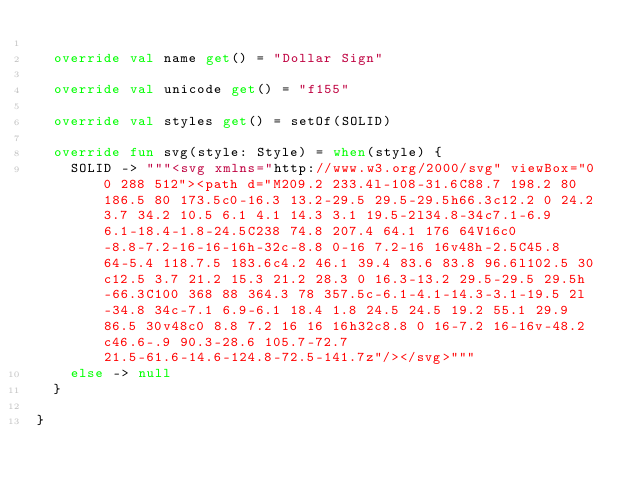<code> <loc_0><loc_0><loc_500><loc_500><_Kotlin_>	
	override val name get() = "Dollar Sign"
	
	override val unicode get() = "f155"
	
	override val styles get() = setOf(SOLID)
	
	override fun svg(style: Style) = when(style) {
		SOLID -> """<svg xmlns="http://www.w3.org/2000/svg" viewBox="0 0 288 512"><path d="M209.2 233.4l-108-31.6C88.7 198.2 80 186.5 80 173.5c0-16.3 13.2-29.5 29.5-29.5h66.3c12.2 0 24.2 3.7 34.2 10.5 6.1 4.1 14.3 3.1 19.5-2l34.8-34c7.1-6.9 6.1-18.4-1.8-24.5C238 74.8 207.4 64.1 176 64V16c0-8.8-7.2-16-16-16h-32c-8.8 0-16 7.2-16 16v48h-2.5C45.8 64-5.4 118.7.5 183.6c4.2 46.1 39.4 83.6 83.8 96.6l102.5 30c12.5 3.7 21.2 15.3 21.2 28.3 0 16.3-13.2 29.5-29.5 29.5h-66.3C100 368 88 364.3 78 357.5c-6.1-4.1-14.3-3.1-19.5 2l-34.8 34c-7.1 6.9-6.1 18.4 1.8 24.5 24.5 19.2 55.1 29.9 86.5 30v48c0 8.8 7.2 16 16 16h32c8.8 0 16-7.2 16-16v-48.2c46.6-.9 90.3-28.6 105.7-72.7 21.5-61.6-14.6-124.8-72.5-141.7z"/></svg>"""
		else -> null
	}
	
}
</code> 